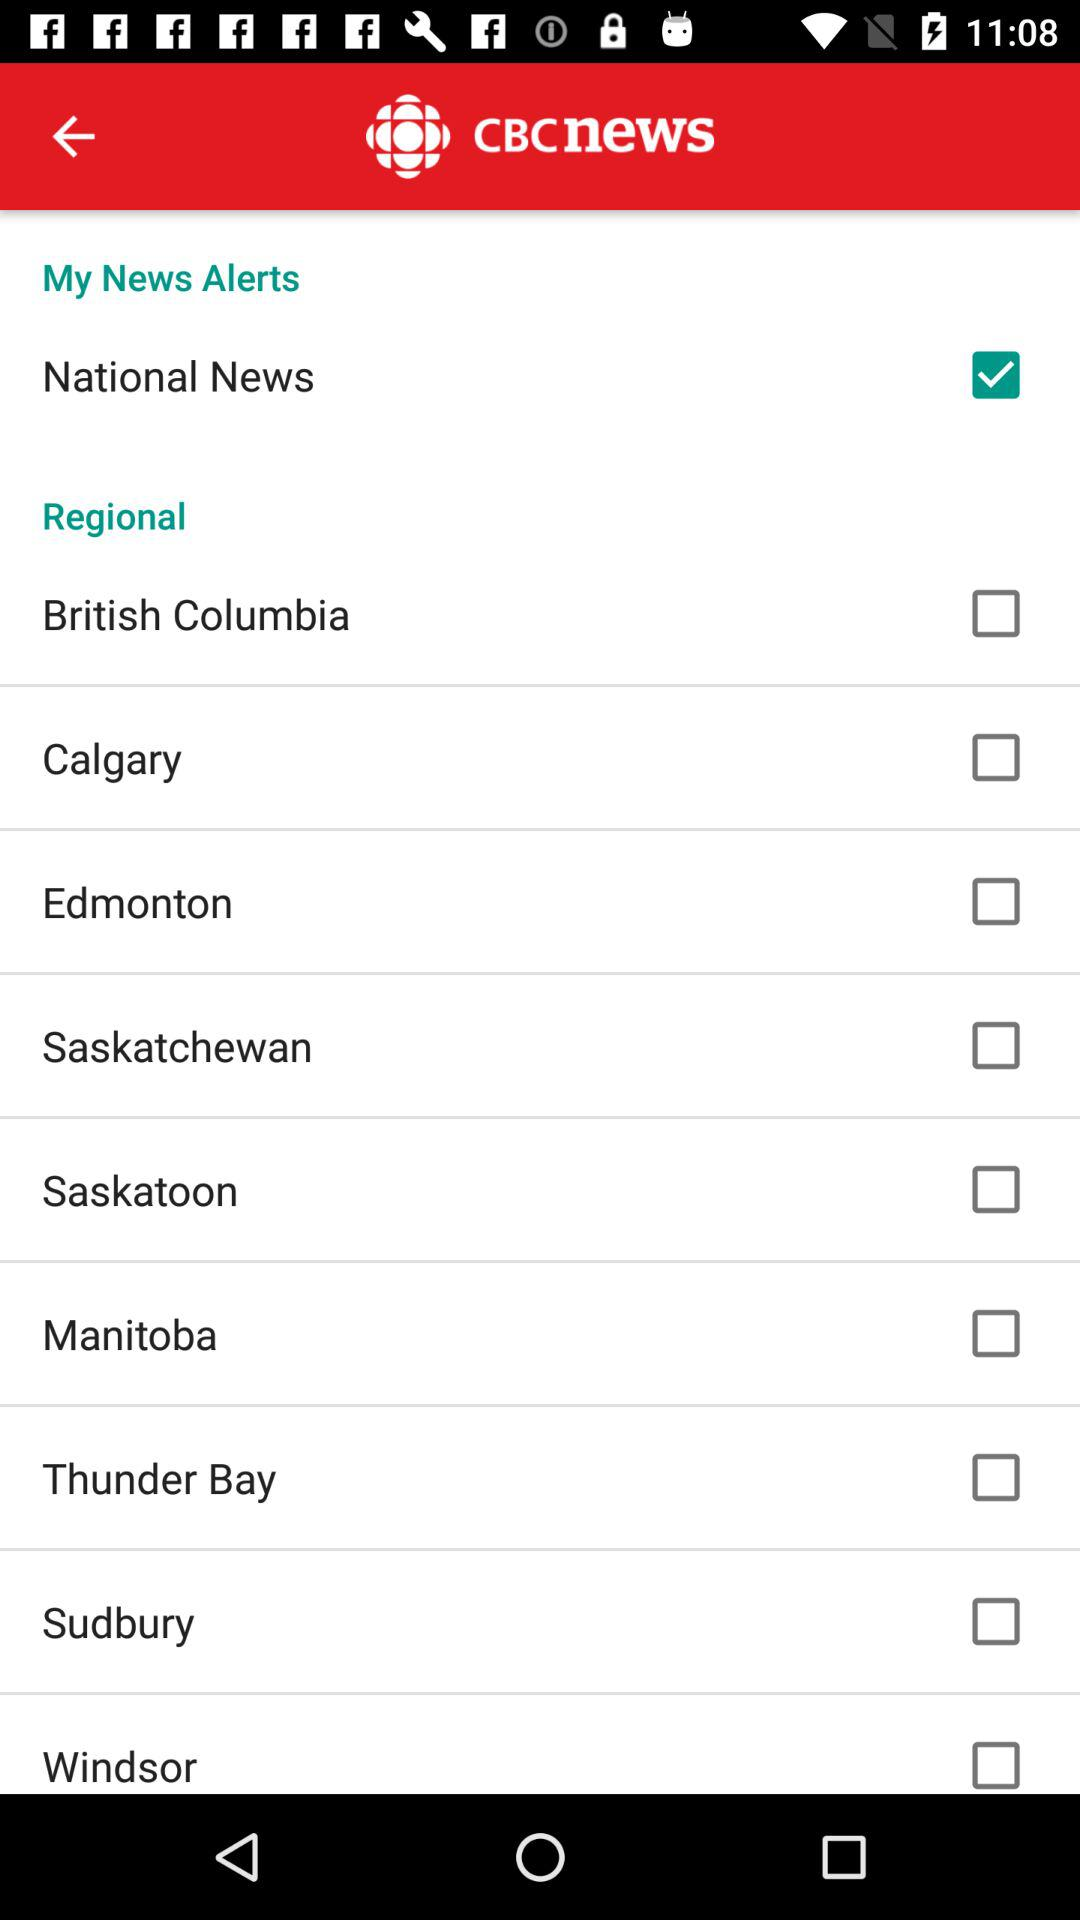What is the status of the "Manitoba" option? The status of the "Manitoba" option is "off". 